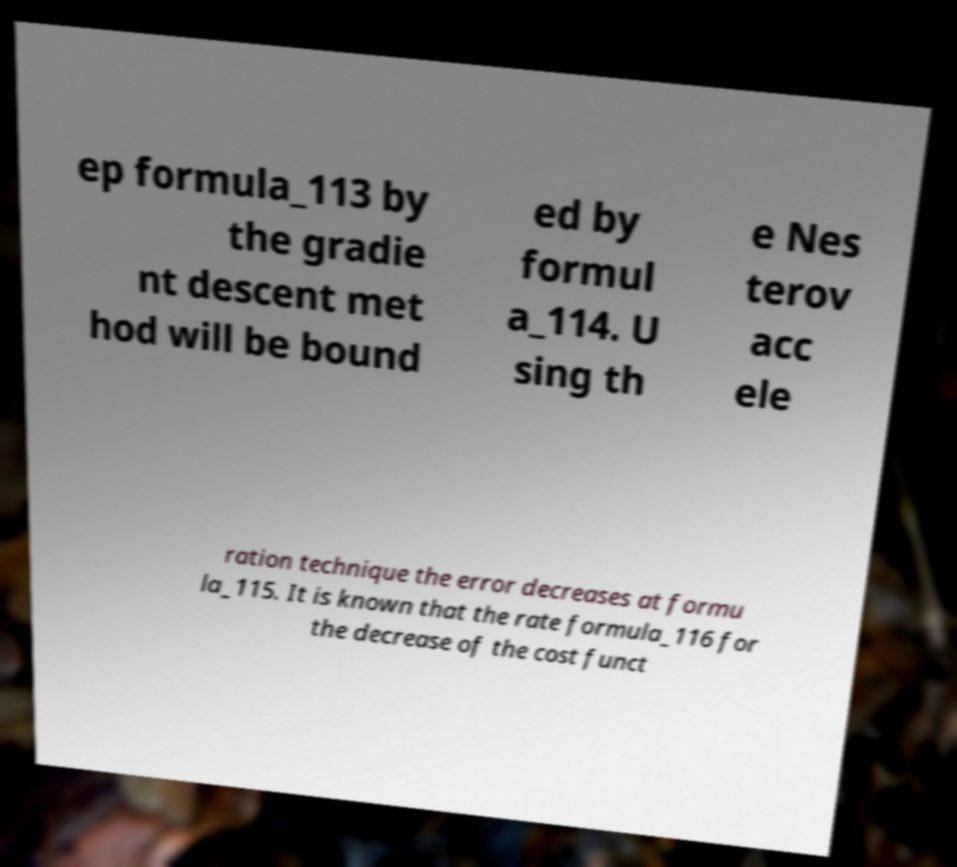Can you accurately transcribe the text from the provided image for me? ep formula_113 by the gradie nt descent met hod will be bound ed by formul a_114. U sing th e Nes terov acc ele ration technique the error decreases at formu la_115. It is known that the rate formula_116 for the decrease of the cost funct 